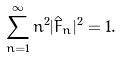Convert formula to latex. <formula><loc_0><loc_0><loc_500><loc_500>\sum _ { n = 1 } ^ { \infty } n ^ { 2 } | \hat { F } _ { n } | ^ { 2 } = 1 .</formula> 